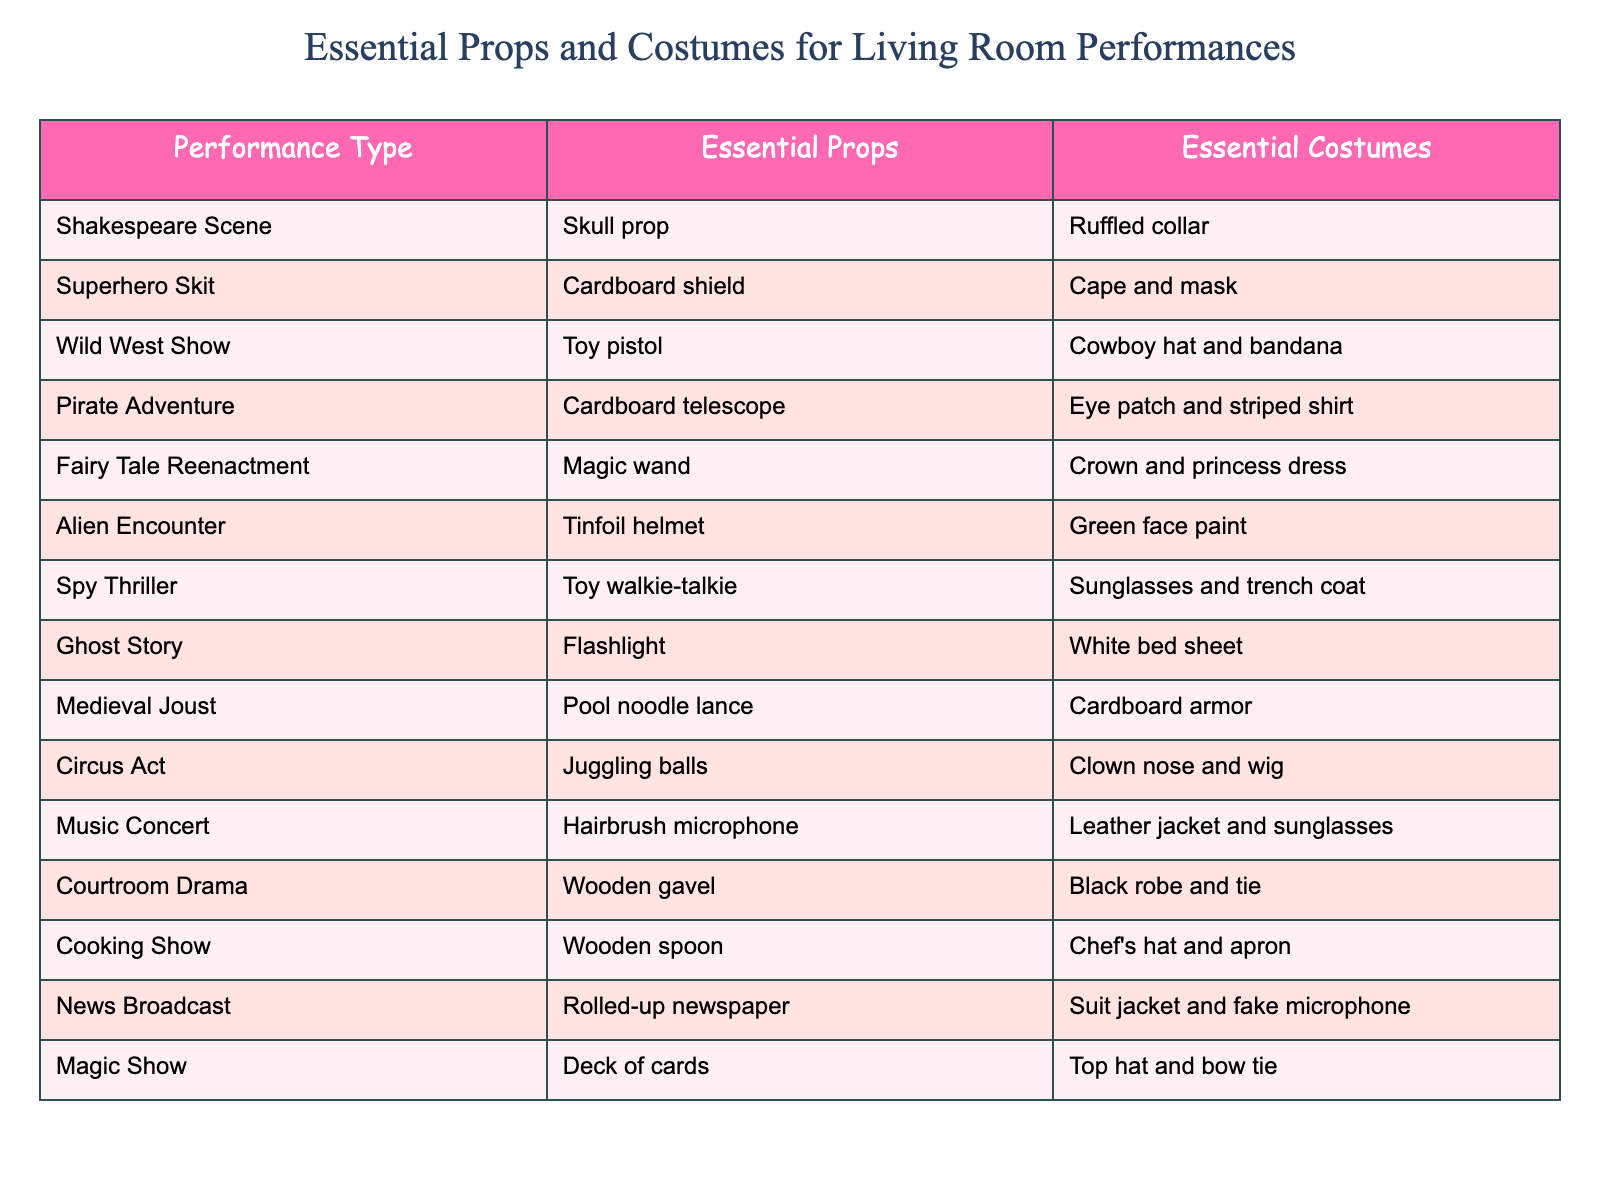What prop is essential for a cooking show? The table shows that the essential prop for a cooking show is a wooden spoon.
Answer: Wooden spoon Which performance type requires an eye patch? According to the table, the performance type that requires an eye patch is the Pirate Adventure.
Answer: Pirate Adventure Does the circus act require a chef's hat? By looking at the table, the circus act does not require a chef's hat; it actually mentions juggling balls and a clown nose.
Answer: No Which performance types include a helmet among the essential props? The table lists two performances that require a helmet: the Alien Encounter (tinfoil helmet) and the Medieval Joust (not directly mentioned as a helmet, but it mentions cardboard armor). In this case, the Alien Encounter distinctly mentions a helmet.
Answer: Alien Encounter How many performance types use a costume with a dress? Upon reviewing the table, only one performance type explicitly mentions a dress, which is the Fairy Tale Reenactment that requires a crown and princess dress.
Answer: One What is the primary costume for the superhero skit? For the superhero skit, the table indicates that the primary costume is a cape and mask.
Answer: Cape and mask How many total essential props include some sort of weapon? The data shows that the following performance types include weapons: Wild West Show (toy pistol), Pirate Adventure (cardboard telescope), Spy Thriller (toy walkie-talkie), and Medieval Joust (pool noodle lance), totaling four performance types.
Answer: Four Is a crown used in any performance type? Yes, according to the table, the crown is an essential costume for the Fairy Tale Reenactment.
Answer: Yes Which performance has the most unique essential prop? If we analyze the table for uniqueness, the Alien Encounter suggests a tinfoil helmet, which is distinctive compared to the other common props that resemble traditional ones like shields or a gavel.
Answer: Alien Encounter 